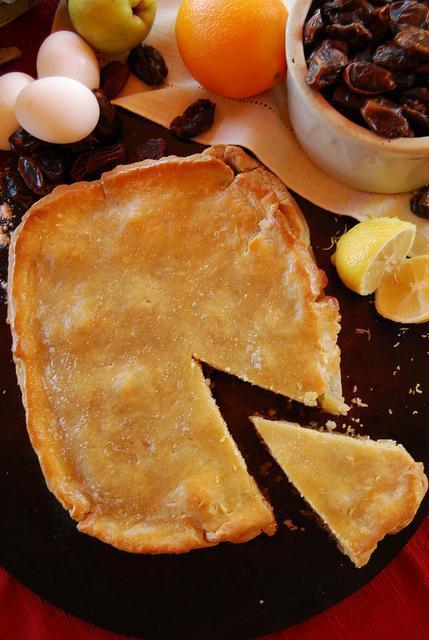How many eggs are in the picture?
Give a very brief answer. 3. How many oranges are there?
Give a very brief answer. 1. How many sandwiches are in the picture?
Give a very brief answer. 2. 